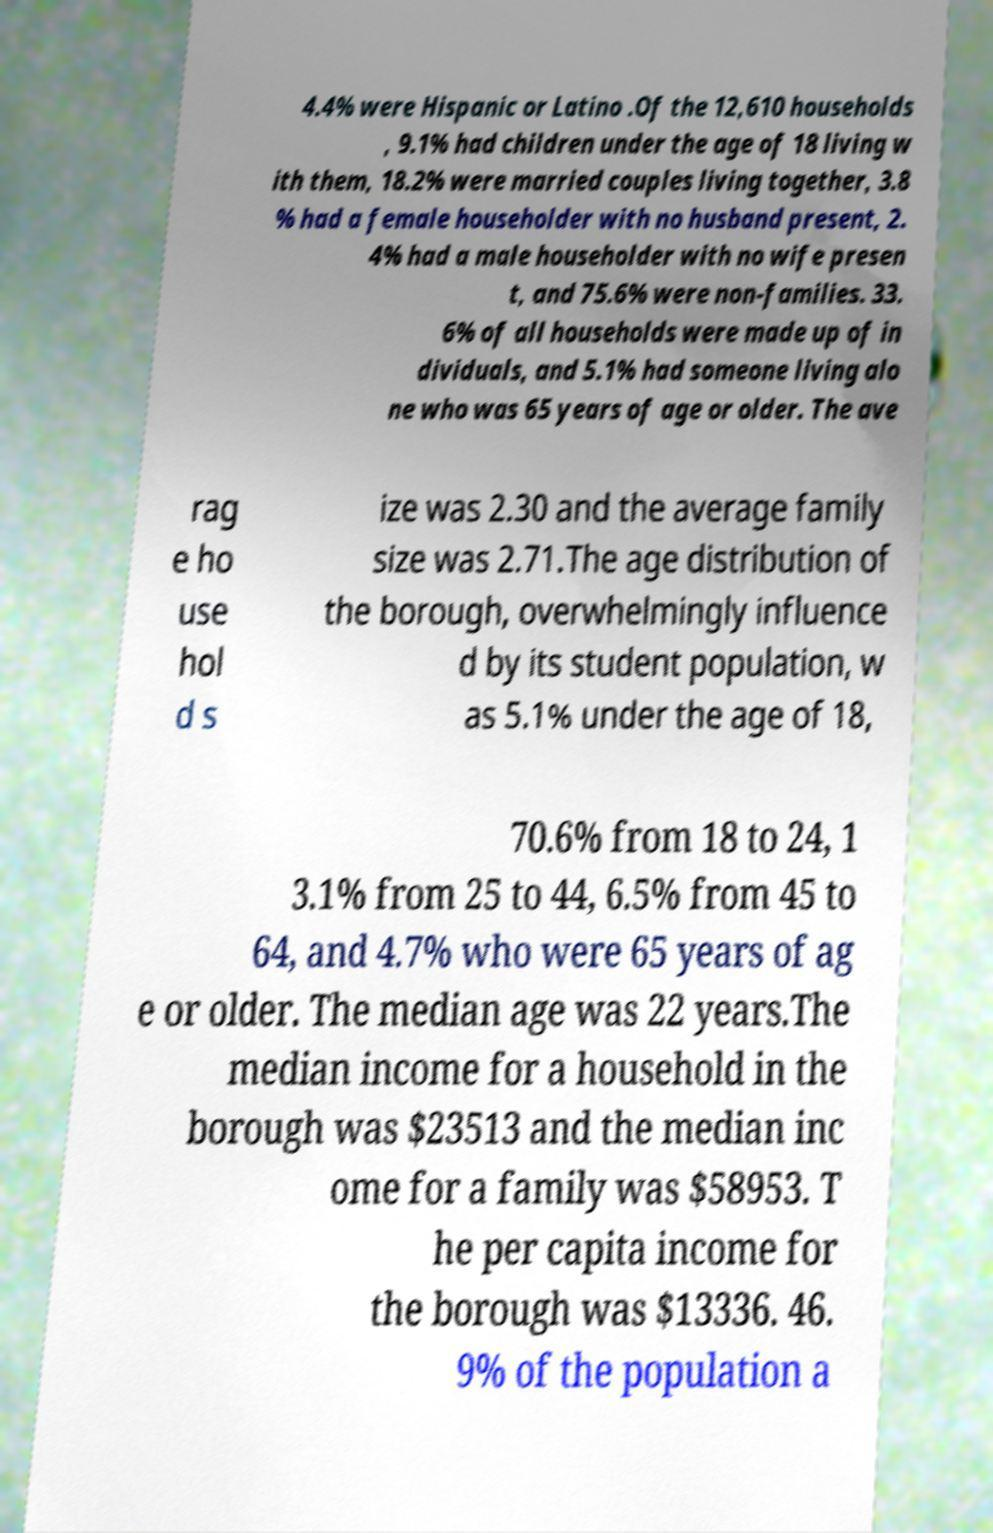Can you read and provide the text displayed in the image?This photo seems to have some interesting text. Can you extract and type it out for me? 4.4% were Hispanic or Latino .Of the 12,610 households , 9.1% had children under the age of 18 living w ith them, 18.2% were married couples living together, 3.8 % had a female householder with no husband present, 2. 4% had a male householder with no wife presen t, and 75.6% were non-families. 33. 6% of all households were made up of in dividuals, and 5.1% had someone living alo ne who was 65 years of age or older. The ave rag e ho use hol d s ize was 2.30 and the average family size was 2.71.The age distribution of the borough, overwhelmingly influence d by its student population, w as 5.1% under the age of 18, 70.6% from 18 to 24, 1 3.1% from 25 to 44, 6.5% from 45 to 64, and 4.7% who were 65 years of ag e or older. The median age was 22 years.The median income for a household in the borough was $23513 and the median inc ome for a family was $58953. T he per capita income for the borough was $13336. 46. 9% of the population a 